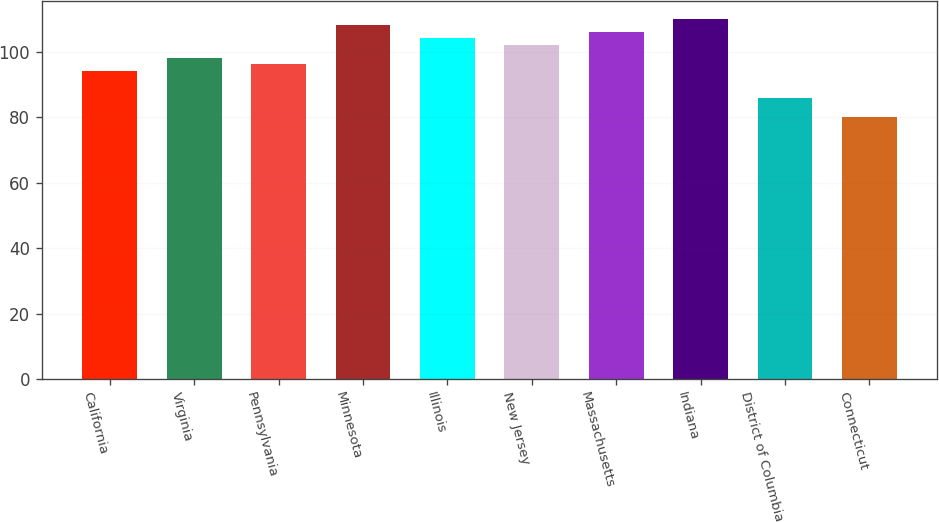<chart> <loc_0><loc_0><loc_500><loc_500><bar_chart><fcel>California<fcel>Virginia<fcel>Pennsylvania<fcel>Minnesota<fcel>Illinois<fcel>New Jersey<fcel>Massachusetts<fcel>Indiana<fcel>District of Columbia<fcel>Connecticut<nl><fcel>94.2<fcel>98.18<fcel>96.19<fcel>108.13<fcel>104.15<fcel>102.16<fcel>106.14<fcel>110.12<fcel>85.79<fcel>80.1<nl></chart> 